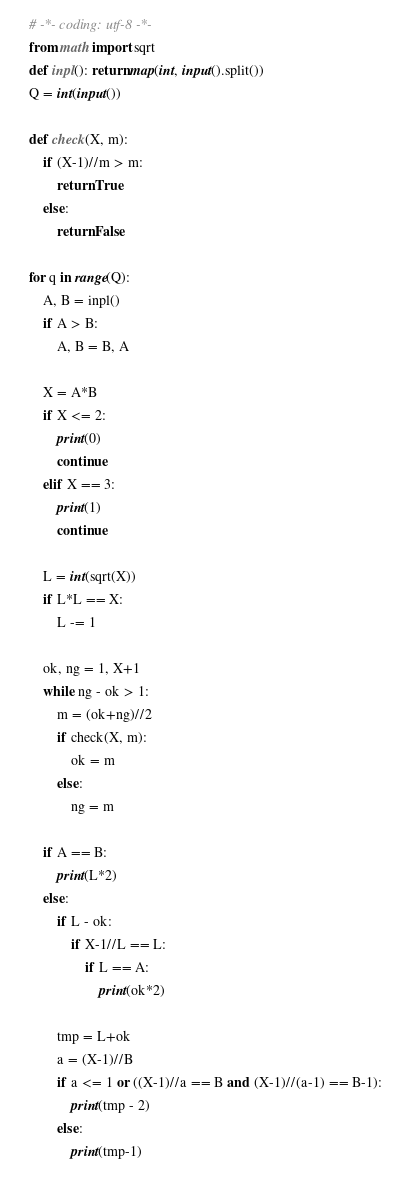Convert code to text. <code><loc_0><loc_0><loc_500><loc_500><_Python_># -*- coding: utf-8 -*-
from math import sqrt
def inpl(): return map(int, input().split())
Q = int(input())

def check(X, m):
    if (X-1)//m > m:
        return True
    else:
        return False

for q in range(Q):
    A, B = inpl()
    if A > B:
        A, B = B, A

    X = A*B
    if X <= 2:
        print(0)
        continue
    elif X == 3:
        print(1)
        continue
    
    L = int(sqrt(X))
    if L*L == X:
        L -= 1

    ok, ng = 1, X+1
    while ng - ok > 1:
        m = (ok+ng)//2
        if check(X, m):
            ok = m
        else:
            ng = m
    
    if A == B:
        print(L*2)
    else:
        if L - ok:
            if X-1//L == L:
                if L == A:
                    print(ok*2)

        tmp = L+ok
        a = (X-1)//B
        if a <= 1 or ((X-1)//a == B and  (X-1)//(a-1) == B-1):
            print(tmp - 2)
        else:
            print(tmp-1)</code> 